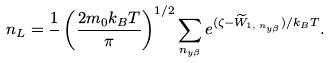Convert formula to latex. <formula><loc_0><loc_0><loc_500><loc_500>n _ { L } = \frac { 1 } { } \left ( \frac { 2 m _ { 0 } k _ { B } T } { \pi } \right ) ^ { 1 / 2 } \sum _ { n _ { y \beta } } e ^ { ( \zeta - \widetilde { W } _ { 1 , \, n _ { y \beta } } ) / k _ { B } T } .</formula> 